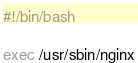<code> <loc_0><loc_0><loc_500><loc_500><_Bash_>#!/bin/bash

exec /usr/sbin/nginx</code> 